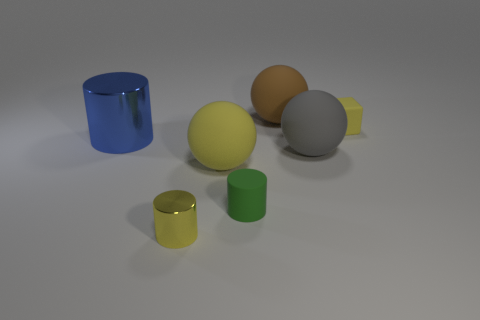Is there anything else that has the same shape as the small yellow matte thing?
Your response must be concise. No. Does the small yellow thing that is right of the brown object have the same material as the cylinder to the right of the tiny metallic thing?
Keep it short and to the point. Yes. Is the number of metallic things that are behind the big gray object the same as the number of brown objects in front of the tiny matte block?
Offer a terse response. No. What material is the tiny cylinder behind the small yellow metallic cylinder?
Your response must be concise. Rubber. Are there fewer cylinders than tiny matte cylinders?
Ensure brevity in your answer.  No. The yellow thing that is left of the small green thing and behind the tiny yellow metal cylinder has what shape?
Your answer should be compact. Sphere. What number of tiny cyan spheres are there?
Provide a succinct answer. 0. What material is the yellow object to the right of the big rubber thing that is behind the cylinder behind the gray matte sphere?
Your answer should be compact. Rubber. There is a big object that is on the left side of the tiny yellow cylinder; how many spheres are behind it?
Keep it short and to the point. 1. What is the color of the other metallic object that is the same shape as the small yellow metallic thing?
Give a very brief answer. Blue. 